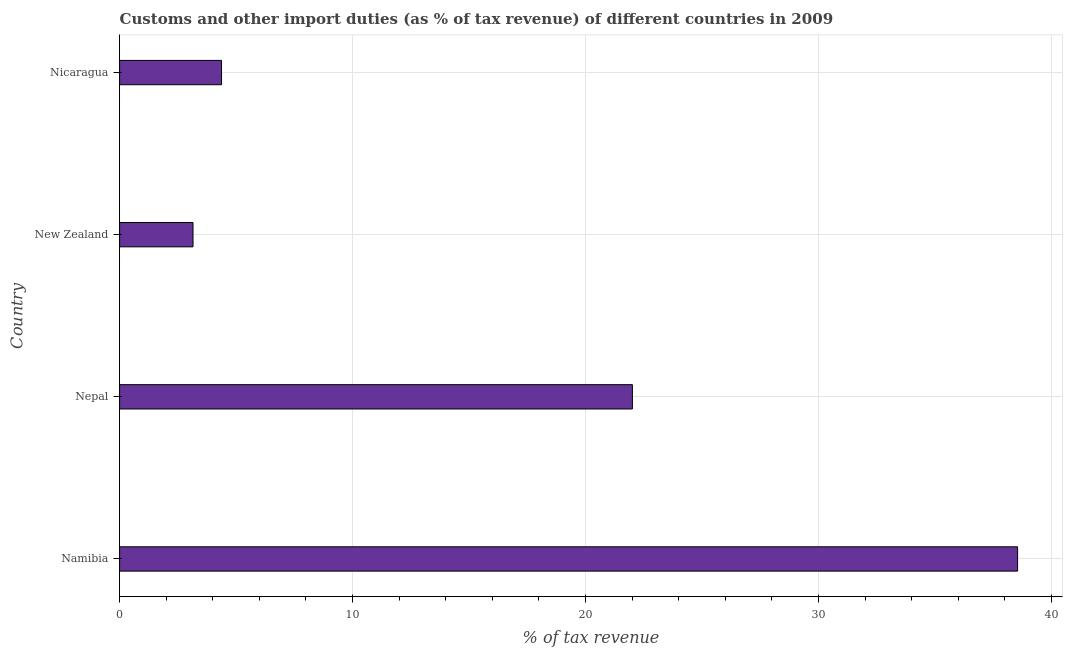What is the title of the graph?
Offer a terse response. Customs and other import duties (as % of tax revenue) of different countries in 2009. What is the label or title of the X-axis?
Provide a succinct answer. % of tax revenue. What is the customs and other import duties in Namibia?
Offer a terse response. 38.55. Across all countries, what is the maximum customs and other import duties?
Make the answer very short. 38.55. Across all countries, what is the minimum customs and other import duties?
Ensure brevity in your answer.  3.15. In which country was the customs and other import duties maximum?
Provide a succinct answer. Namibia. In which country was the customs and other import duties minimum?
Offer a very short reply. New Zealand. What is the sum of the customs and other import duties?
Your response must be concise. 68.08. What is the difference between the customs and other import duties in Nepal and Nicaragua?
Ensure brevity in your answer.  17.64. What is the average customs and other import duties per country?
Give a very brief answer. 17.02. What is the median customs and other import duties?
Your response must be concise. 13.19. What is the ratio of the customs and other import duties in Nepal to that in New Zealand?
Your response must be concise. 6.98. What is the difference between the highest and the second highest customs and other import duties?
Your response must be concise. 16.53. Is the sum of the customs and other import duties in Namibia and Nepal greater than the maximum customs and other import duties across all countries?
Give a very brief answer. Yes. What is the difference between the highest and the lowest customs and other import duties?
Your answer should be compact. 35.39. Are all the bars in the graph horizontal?
Provide a succinct answer. Yes. How many countries are there in the graph?
Make the answer very short. 4. Are the values on the major ticks of X-axis written in scientific E-notation?
Ensure brevity in your answer.  No. What is the % of tax revenue of Namibia?
Offer a very short reply. 38.55. What is the % of tax revenue in Nepal?
Your answer should be very brief. 22.01. What is the % of tax revenue in New Zealand?
Make the answer very short. 3.15. What is the % of tax revenue of Nicaragua?
Your response must be concise. 4.38. What is the difference between the % of tax revenue in Namibia and Nepal?
Keep it short and to the point. 16.53. What is the difference between the % of tax revenue in Namibia and New Zealand?
Offer a terse response. 35.39. What is the difference between the % of tax revenue in Namibia and Nicaragua?
Your response must be concise. 34.17. What is the difference between the % of tax revenue in Nepal and New Zealand?
Keep it short and to the point. 18.86. What is the difference between the % of tax revenue in Nepal and Nicaragua?
Make the answer very short. 17.64. What is the difference between the % of tax revenue in New Zealand and Nicaragua?
Offer a very short reply. -1.22. What is the ratio of the % of tax revenue in Namibia to that in Nepal?
Your answer should be compact. 1.75. What is the ratio of the % of tax revenue in Namibia to that in New Zealand?
Provide a succinct answer. 12.23. What is the ratio of the % of tax revenue in Namibia to that in Nicaragua?
Offer a very short reply. 8.81. What is the ratio of the % of tax revenue in Nepal to that in New Zealand?
Your response must be concise. 6.98. What is the ratio of the % of tax revenue in Nepal to that in Nicaragua?
Offer a terse response. 5.03. What is the ratio of the % of tax revenue in New Zealand to that in Nicaragua?
Keep it short and to the point. 0.72. 